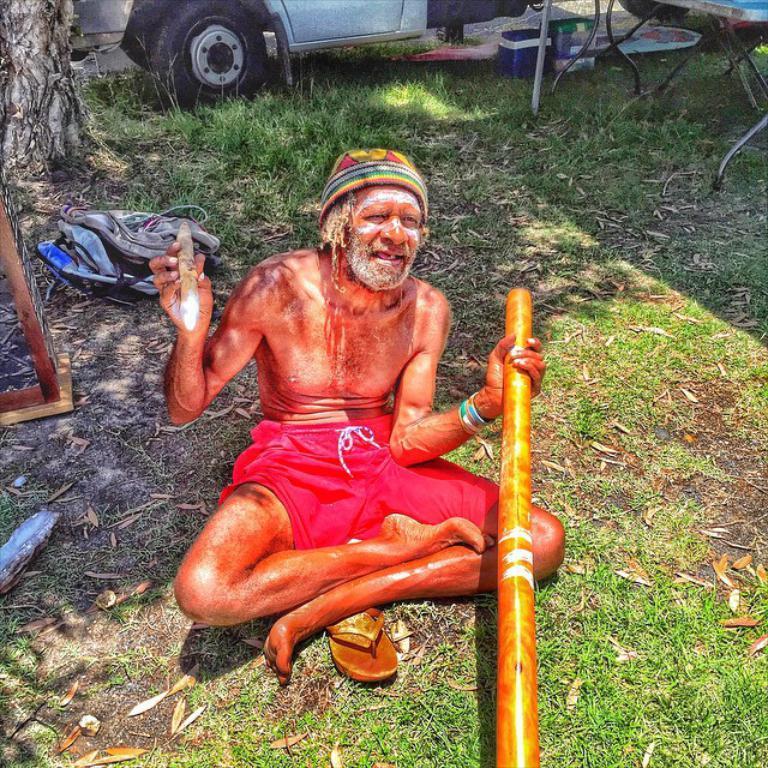Can you describe this image briefly? In this picture I can see a man sitting on the grass and holding stick, behind we can see a vehicle, tree trunk. 